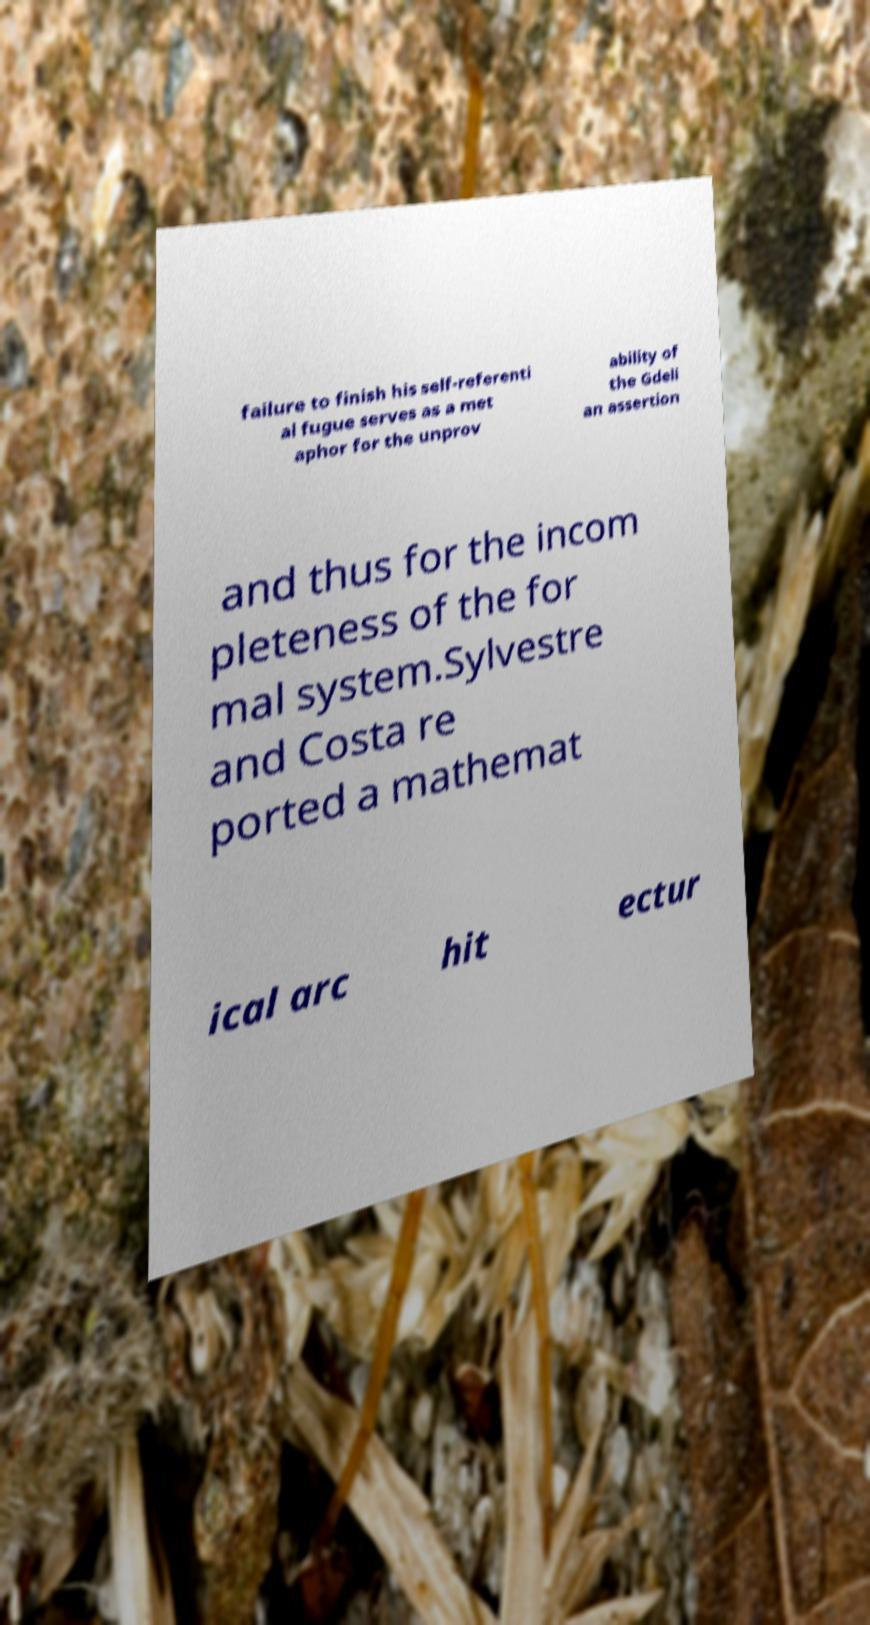Can you accurately transcribe the text from the provided image for me? failure to finish his self-referenti al fugue serves as a met aphor for the unprov ability of the Gdeli an assertion and thus for the incom pleteness of the for mal system.Sylvestre and Costa re ported a mathemat ical arc hit ectur 